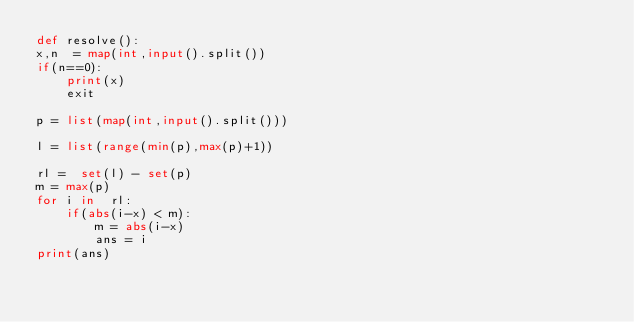<code> <loc_0><loc_0><loc_500><loc_500><_Python_>def resolve():
x,n  = map(int,input().split())
if(n==0):
    print(x)
    exit

p = list(map(int,input().split()))

l = list(range(min(p),max(p)+1))

rl =  set(l) - set(p)
m = max(p)
for i in  rl:
    if(abs(i-x) < m):
        m = abs(i-x)
        ans = i
print(ans)</code> 